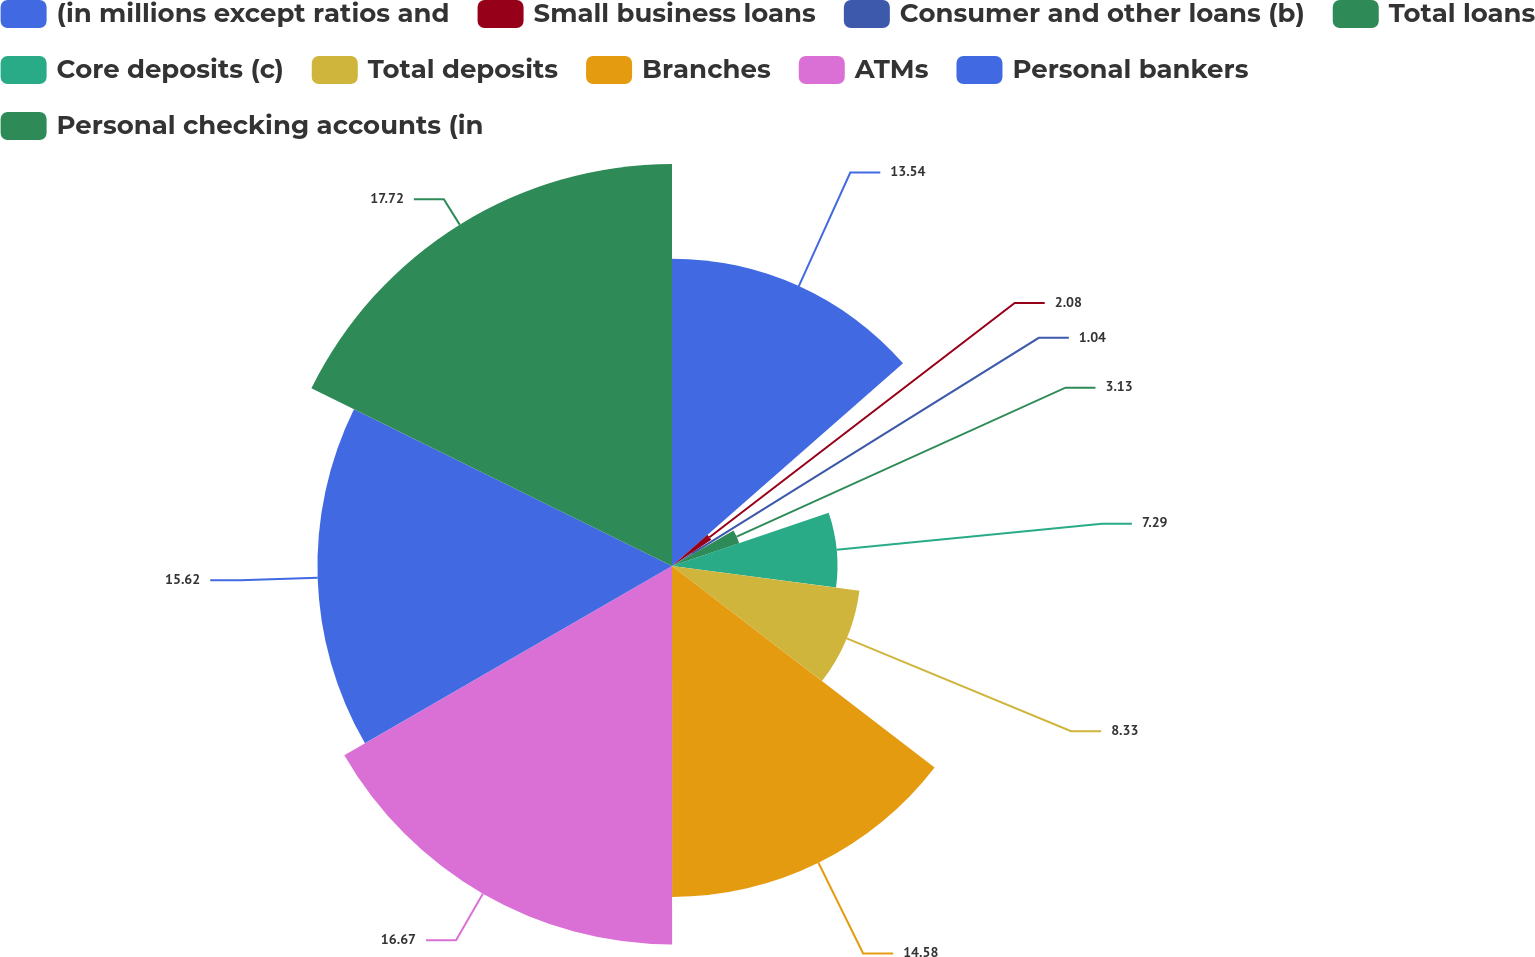<chart> <loc_0><loc_0><loc_500><loc_500><pie_chart><fcel>(in millions except ratios and<fcel>Small business loans<fcel>Consumer and other loans (b)<fcel>Total loans<fcel>Core deposits (c)<fcel>Total deposits<fcel>Branches<fcel>ATMs<fcel>Personal bankers<fcel>Personal checking accounts (in<nl><fcel>13.54%<fcel>2.08%<fcel>1.04%<fcel>3.13%<fcel>7.29%<fcel>8.33%<fcel>14.58%<fcel>16.67%<fcel>15.62%<fcel>17.71%<nl></chart> 